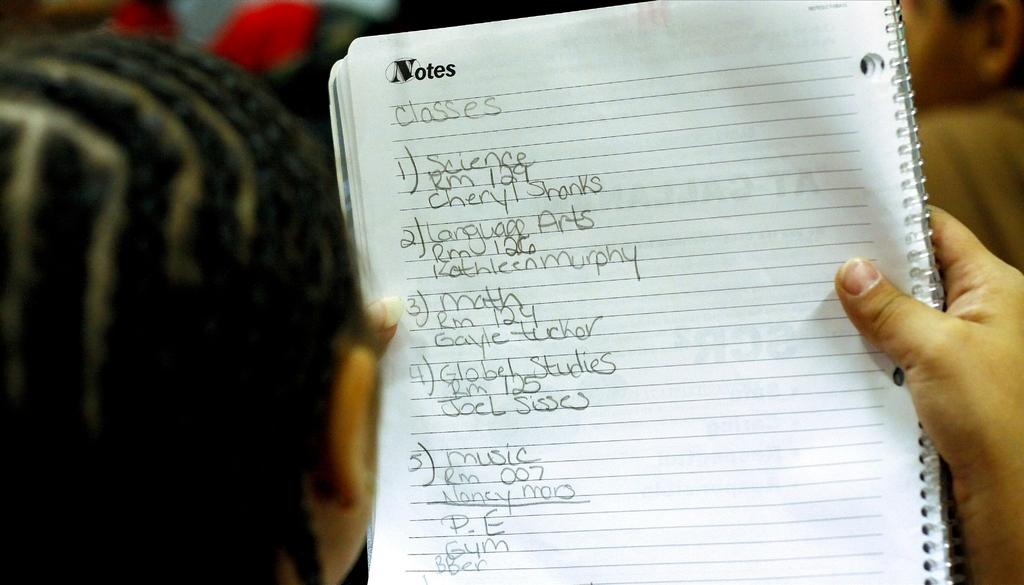Provide a one-sentence caption for the provided image. Woman is looking at some notes in a notebook. 